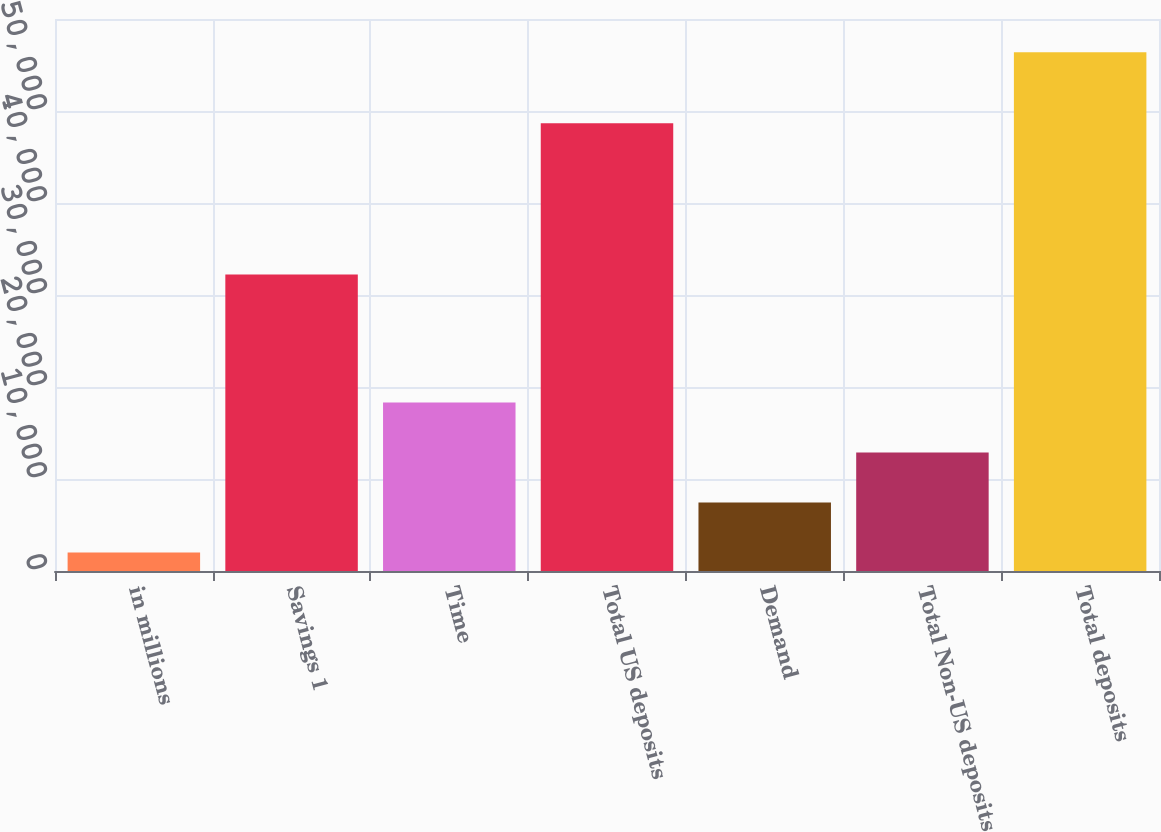Convert chart to OTSL. <chart><loc_0><loc_0><loc_500><loc_500><bar_chart><fcel>in millions<fcel>Savings 1<fcel>Time<fcel>Total US deposits<fcel>Demand<fcel>Total Non-US deposits<fcel>Total deposits<nl><fcel>2012<fcel>32235<fcel>18328.1<fcel>48668<fcel>7450.7<fcel>12889.4<fcel>56399<nl></chart> 